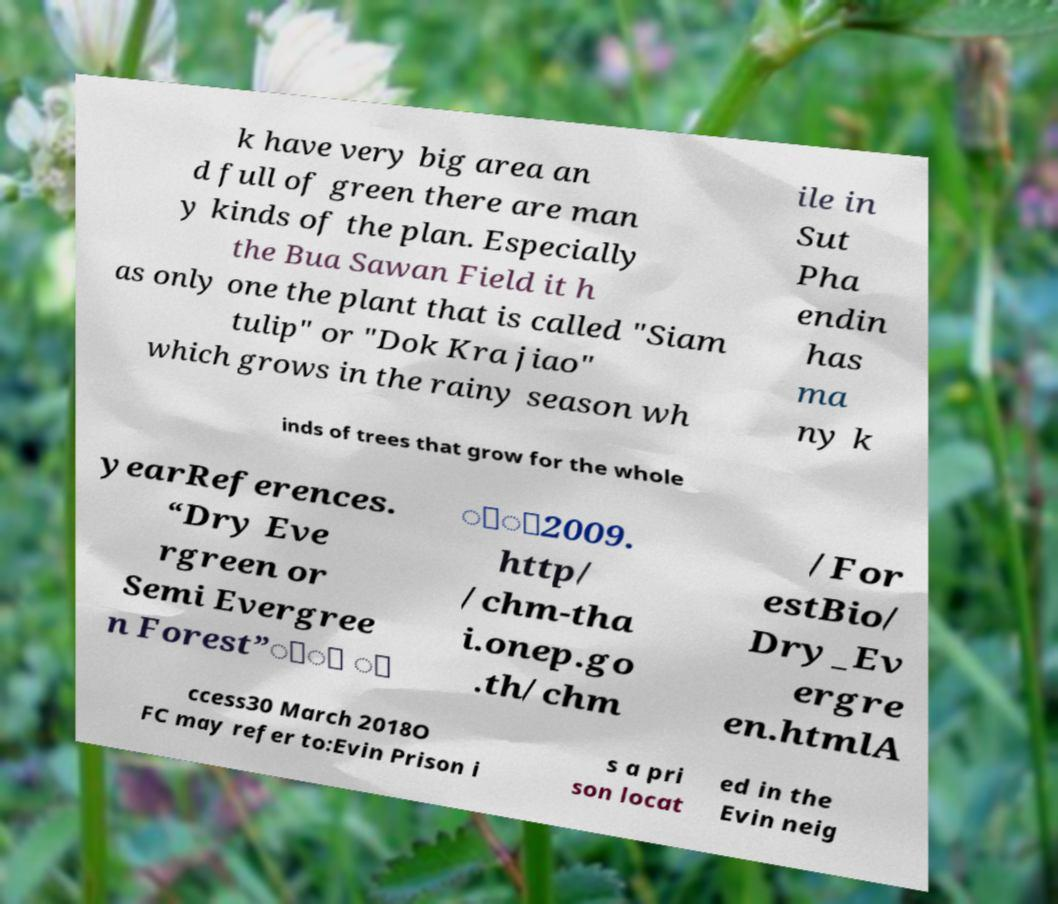Please read and relay the text visible in this image. What does it say? k have very big area an d full of green there are man y kinds of the plan. Especially the Bua Sawan Field it h as only one the plant that is called "Siam tulip" or "Dok Kra jiao" which grows in the rainy season wh ile in Sut Pha endin has ma ny k inds of trees that grow for the whole yearReferences. “Dry Eve rgreen or Semi Evergree n Forest”ัั ั ิุ2009. http/ /chm-tha i.onep.go .th/chm /For estBio/ Dry_Ev ergre en.htmlA ccess30 March 2018O FC may refer to:Evin Prison i s a pri son locat ed in the Evin neig 